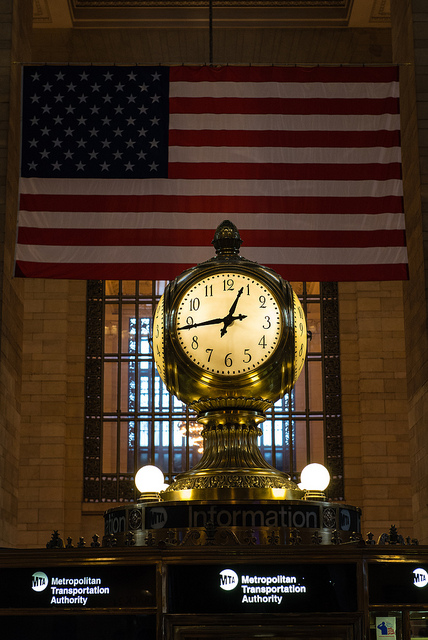Read and extract the text from this image. Metropolitan Transportation Authority MTA MTA MTA MTA Information MTA Authority Transportation Metropolitan 2 4 3 11 10 9 8 7 6 5 8 9 4 3 2 1 12 